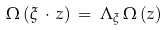Convert formula to latex. <formula><loc_0><loc_0><loc_500><loc_500>\Omega \left ( \xi \, \cdot \, z \right ) \, = \, \Lambda _ { \xi } \, \Omega \left ( z \right )</formula> 